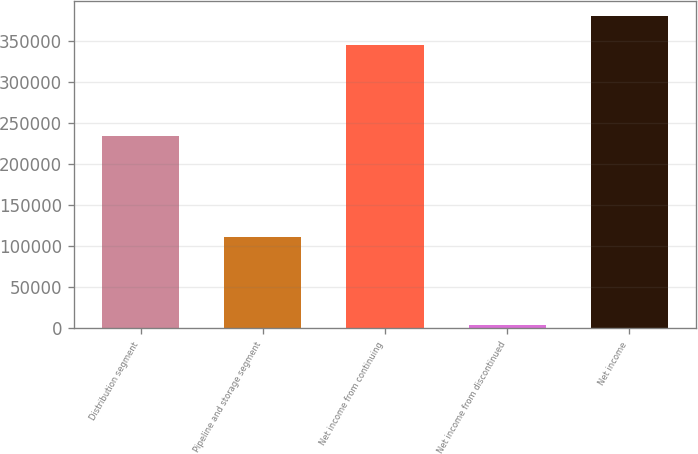Convert chart. <chart><loc_0><loc_0><loc_500><loc_500><bar_chart><fcel>Distribution segment<fcel>Pipeline and storage segment<fcel>Net income from continuing<fcel>Net income from discontinued<fcel>Net income<nl><fcel>233830<fcel>111712<fcel>345542<fcel>4562<fcel>380096<nl></chart> 